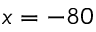<formula> <loc_0><loc_0><loc_500><loc_500>x = - 8 0</formula> 